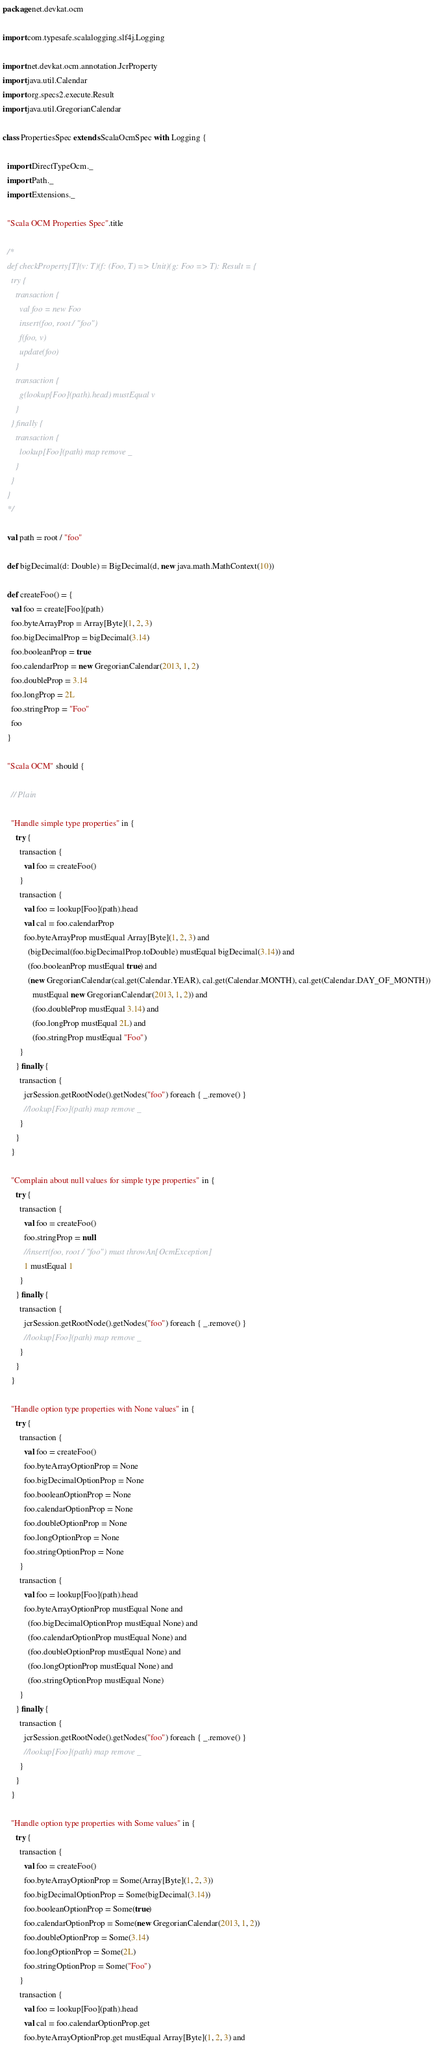<code> <loc_0><loc_0><loc_500><loc_500><_Scala_>package net.devkat.ocm

import com.typesafe.scalalogging.slf4j.Logging

import net.devkat.ocm.annotation.JcrProperty
import java.util.Calendar
import org.specs2.execute.Result
import java.util.GregorianCalendar

class PropertiesSpec extends ScalaOcmSpec with Logging {

  import DirectTypeOcm._
  import Path._
  import Extensions._

  "Scala OCM Properties Spec".title

  /*
  def checkProperty[T](v: T)(f: (Foo, T) => Unit)(g: Foo => T): Result = {
    try {
      transaction {
        val foo = new Foo
        insert(foo, root / "foo")
        f(foo, v)
        update(foo)
      }
      transaction {
        g(lookup[Foo](path).head) mustEqual v
      }
    } finally {
      transaction {
        lookup[Foo](path) map remove _
      }
    }
  }
  */

  val path = root / "foo"

  def bigDecimal(d: Double) = BigDecimal(d, new java.math.MathContext(10))

  def createFoo() = {
    val foo = create[Foo](path)
    foo.byteArrayProp = Array[Byte](1, 2, 3)
    foo.bigDecimalProp = bigDecimal(3.14)
    foo.booleanProp = true
    foo.calendarProp = new GregorianCalendar(2013, 1, 2)
    foo.doubleProp = 3.14
    foo.longProp = 2L
    foo.stringProp = "Foo"
    foo
  }

  "Scala OCM" should {

    // Plain

    "Handle simple type properties" in {
      try {
        transaction {
          val foo = createFoo()
        }
        transaction {
          val foo = lookup[Foo](path).head
          val cal = foo.calendarProp
          foo.byteArrayProp mustEqual Array[Byte](1, 2, 3) and
            (bigDecimal(foo.bigDecimalProp.toDouble) mustEqual bigDecimal(3.14)) and
            (foo.booleanProp mustEqual true) and
            (new GregorianCalendar(cal.get(Calendar.YEAR), cal.get(Calendar.MONTH), cal.get(Calendar.DAY_OF_MONTH))
              mustEqual new GregorianCalendar(2013, 1, 2)) and
              (foo.doubleProp mustEqual 3.14) and
              (foo.longProp mustEqual 2L) and
              (foo.stringProp mustEqual "Foo")
        }
      } finally {
        transaction {
          jcrSession.getRootNode().getNodes("foo") foreach { _.remove() }
          //lookup[Foo](path) map remove _
        }
      }
    }

    "Complain about null values for simple type properties" in {
      try {
        transaction {
          val foo = createFoo()
          foo.stringProp = null
          //insert(foo, root / "foo") must throwAn[OcmException]
          1 mustEqual 1
        }
      } finally {
        transaction {
          jcrSession.getRootNode().getNodes("foo") foreach { _.remove() }
          //lookup[Foo](path) map remove _
        }
      }
    }

    "Handle option type properties with None values" in {
      try {
        transaction {
          val foo = createFoo()
          foo.byteArrayOptionProp = None
          foo.bigDecimalOptionProp = None
          foo.booleanOptionProp = None
          foo.calendarOptionProp = None
          foo.doubleOptionProp = None
          foo.longOptionProp = None
          foo.stringOptionProp = None
        }
        transaction {
          val foo = lookup[Foo](path).head
          foo.byteArrayOptionProp mustEqual None and
            (foo.bigDecimalOptionProp mustEqual None) and
            (foo.calendarOptionProp mustEqual None) and
            (foo.doubleOptionProp mustEqual None) and
            (foo.longOptionProp mustEqual None) and
            (foo.stringOptionProp mustEqual None)
        }
      } finally {
        transaction {
          jcrSession.getRootNode().getNodes("foo") foreach { _.remove() }
          //lookup[Foo](path) map remove _
        }
      }
    }

    "Handle option type properties with Some values" in {
      try {
        transaction {
          val foo = createFoo()
          foo.byteArrayOptionProp = Some(Array[Byte](1, 2, 3))
          foo.bigDecimalOptionProp = Some(bigDecimal(3.14))
          foo.booleanOptionProp = Some(true)
          foo.calendarOptionProp = Some(new GregorianCalendar(2013, 1, 2))
          foo.doubleOptionProp = Some(3.14)
          foo.longOptionProp = Some(2L)
          foo.stringOptionProp = Some("Foo")
        }
        transaction {
          val foo = lookup[Foo](path).head
          val cal = foo.calendarOptionProp.get
          foo.byteArrayOptionProp.get mustEqual Array[Byte](1, 2, 3) and</code> 